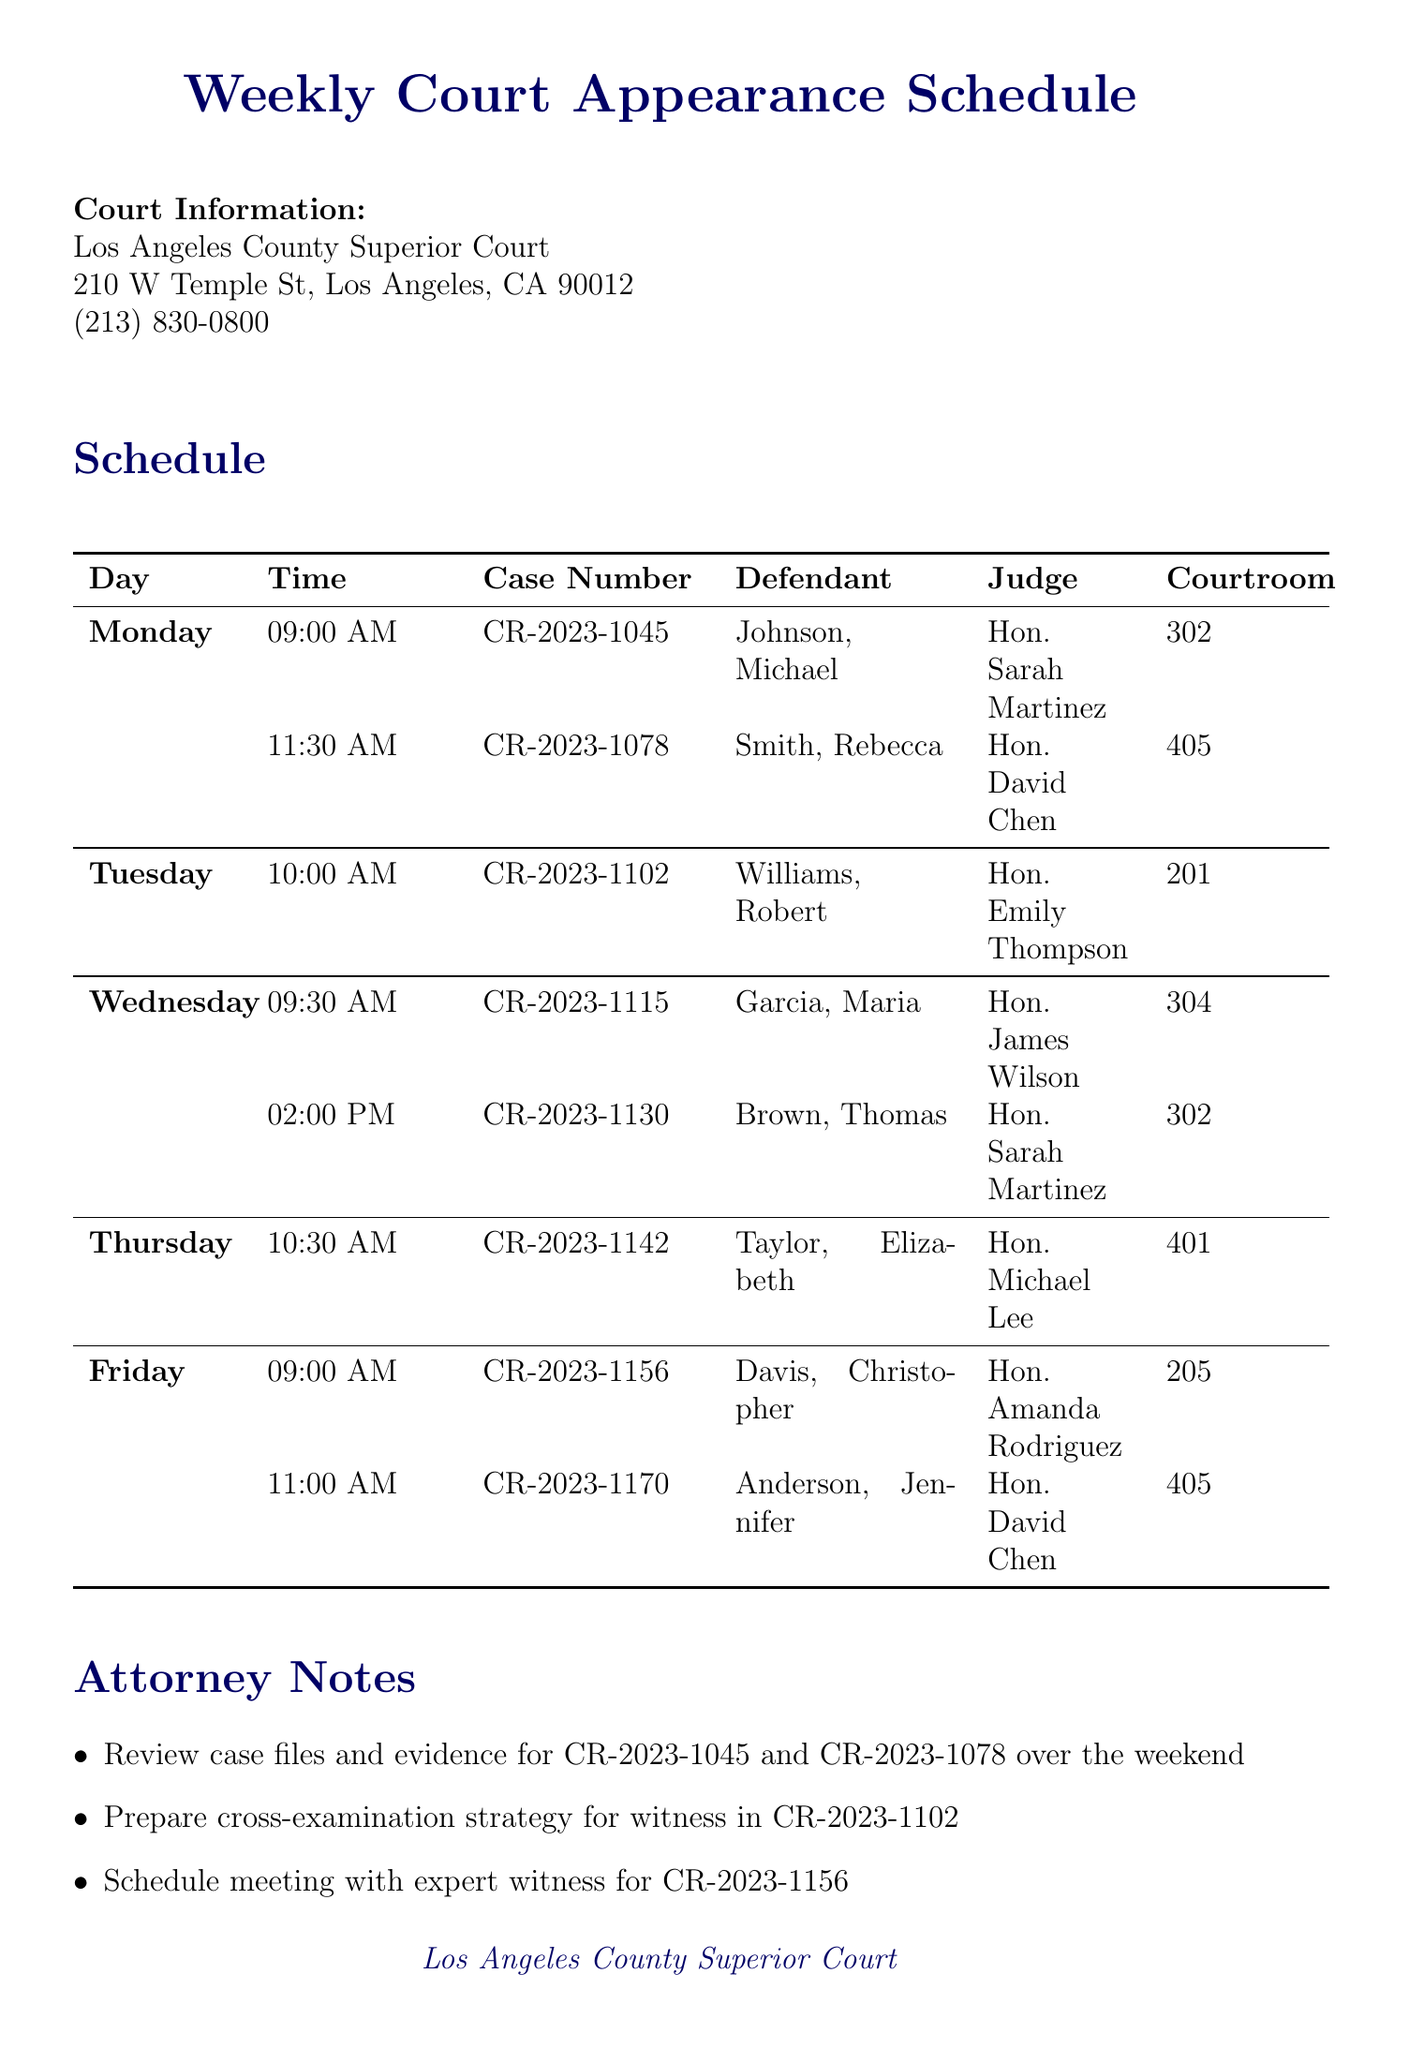What time is the case for Johnson, Michael scheduled? The schedule states that Johnson, Michael's case is set for 09:00 AM on Monday.
Answer: 09:00 AM Who is the judge for the case CR-2023-1170? The judge listed for CR-2023-1170 is Hon. David Chen.
Answer: Hon. David Chen What charge is associated with CR-2023-1045? The charge for CR-2023-1045 is Aggravated Assault as noted in the document.
Answer: Aggravated Assault How many cases are scheduled for Friday? The document lists two cases scheduled for Friday: CR-2023-1156 and CR-2023-1170.
Answer: 2 Which courtroom is assigned for the case on Tuesday? The courtroom assigned for the case on Tuesday is courtroom 201.
Answer: 201 What is one action noted for CR-2023-1130? The document mentions confirming plea deal terms with the prosecutor for CR-2023-1130.
Answer: Confirm plea deal terms What is the location of the Los Angeles County Superior Court? The address for the Los Angeles County Superior Court is 210 W Temple St, Los Angeles, CA 90012.
Answer: 210 W Temple St, Los Angeles, CA 90012 Which defendant is charged with Domestic Violence? The document indicates that Elizabeth Taylor is charged with Domestic Violence.
Answer: Taylor, Elizabeth What is the early arrival reminder for courtroom 405? The reminder states to arrive 30 minutes early to discuss strategy with the client for case CR-2023-1170 in courtroom 405.
Answer: 30 minutes early 